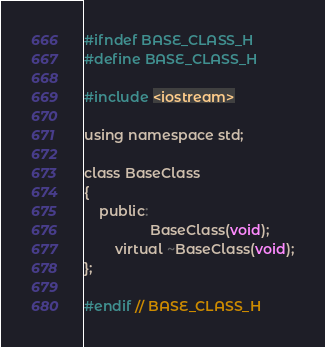<code> <loc_0><loc_0><loc_500><loc_500><_C_>#ifndef BASE_CLASS_H
#define BASE_CLASS_H

#include <iostream>

using namespace std;

class BaseClass
{
    public:
                 BaseClass(void);
        virtual ~BaseClass(void);
};

#endif // BASE_CLASS_H
</code> 